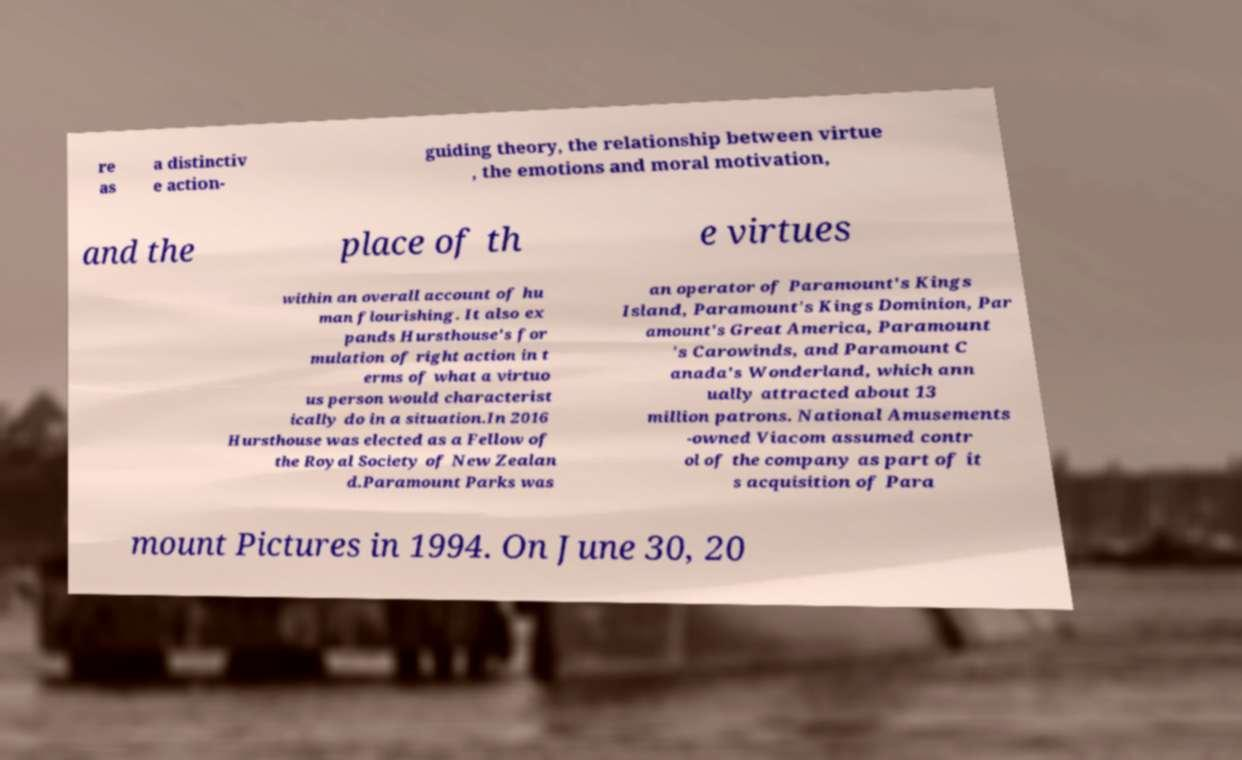Could you assist in decoding the text presented in this image and type it out clearly? re as a distinctiv e action- guiding theory, the relationship between virtue , the emotions and moral motivation, and the place of th e virtues within an overall account of hu man flourishing. It also ex pands Hursthouse's for mulation of right action in t erms of what a virtuo us person would characterist ically do in a situation.In 2016 Hursthouse was elected as a Fellow of the Royal Society of New Zealan d.Paramount Parks was an operator of Paramount's Kings Island, Paramount's Kings Dominion, Par amount's Great America, Paramount 's Carowinds, and Paramount C anada's Wonderland, which ann ually attracted about 13 million patrons. National Amusements -owned Viacom assumed contr ol of the company as part of it s acquisition of Para mount Pictures in 1994. On June 30, 20 